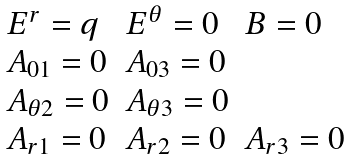Convert formula to latex. <formula><loc_0><loc_0><loc_500><loc_500>\begin{array} { l l l } E ^ { r } = q & E ^ { \theta } = 0 & B = 0 \\ A _ { 0 1 } = 0 & A _ { 0 3 } = 0 \\ A _ { \theta 2 } = 0 & A _ { \theta 3 } = 0 \\ A _ { r 1 } = 0 & A _ { r 2 } = 0 & A _ { r 3 } = 0 \end{array}</formula> 